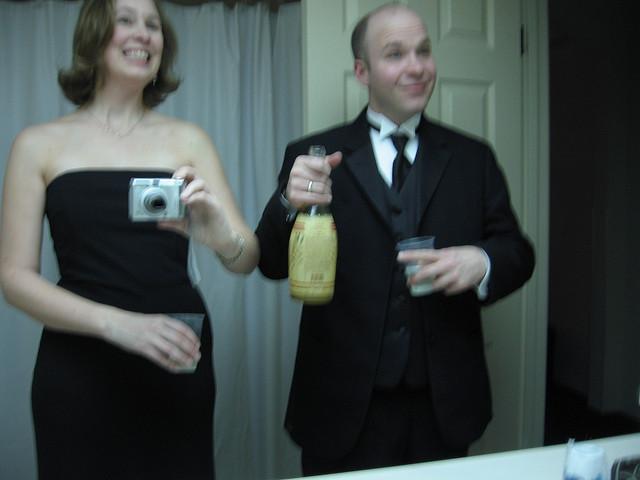How many people are visible?
Give a very brief answer. 2. How many elephants are holding their trunks up in the picture?
Give a very brief answer. 0. 